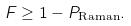Convert formula to latex. <formula><loc_0><loc_0><loc_500><loc_500>F \geq 1 - P _ { \text {Raman} } .</formula> 